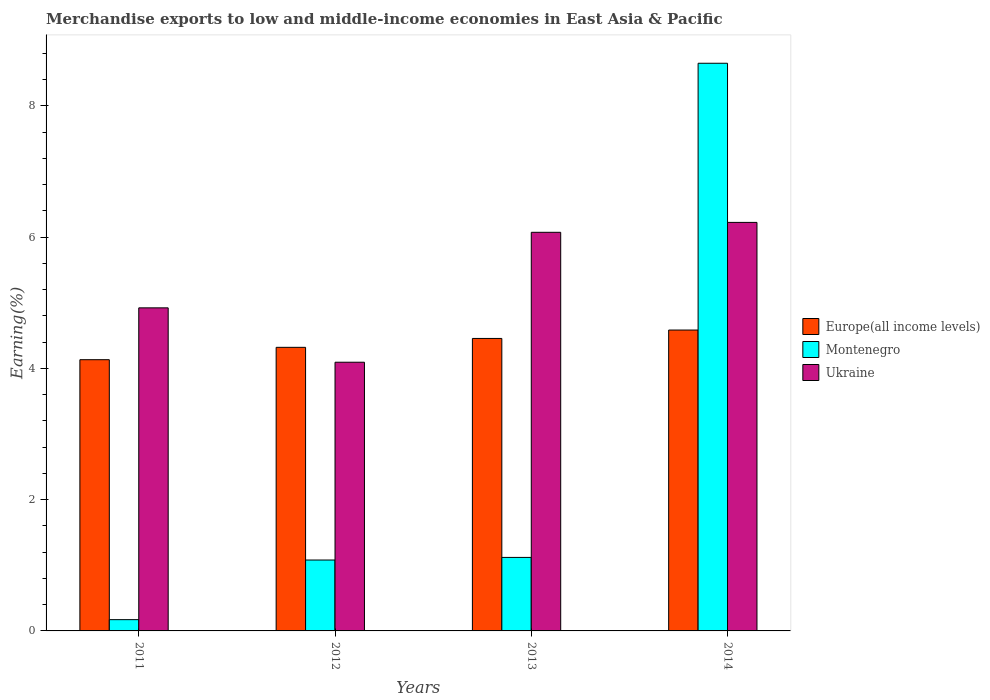How many different coloured bars are there?
Offer a terse response. 3. How many groups of bars are there?
Provide a short and direct response. 4. How many bars are there on the 1st tick from the right?
Make the answer very short. 3. What is the label of the 1st group of bars from the left?
Provide a short and direct response. 2011. What is the percentage of amount earned from merchandise exports in Ukraine in 2014?
Give a very brief answer. 6.23. Across all years, what is the maximum percentage of amount earned from merchandise exports in Montenegro?
Provide a succinct answer. 8.65. Across all years, what is the minimum percentage of amount earned from merchandise exports in Montenegro?
Your answer should be compact. 0.17. In which year was the percentage of amount earned from merchandise exports in Ukraine maximum?
Provide a succinct answer. 2014. In which year was the percentage of amount earned from merchandise exports in Ukraine minimum?
Ensure brevity in your answer.  2012. What is the total percentage of amount earned from merchandise exports in Europe(all income levels) in the graph?
Offer a very short reply. 17.5. What is the difference between the percentage of amount earned from merchandise exports in Europe(all income levels) in 2011 and that in 2013?
Give a very brief answer. -0.32. What is the difference between the percentage of amount earned from merchandise exports in Ukraine in 2014 and the percentage of amount earned from merchandise exports in Europe(all income levels) in 2012?
Offer a terse response. 1.9. What is the average percentage of amount earned from merchandise exports in Montenegro per year?
Give a very brief answer. 2.76. In the year 2014, what is the difference between the percentage of amount earned from merchandise exports in Europe(all income levels) and percentage of amount earned from merchandise exports in Ukraine?
Give a very brief answer. -1.64. In how many years, is the percentage of amount earned from merchandise exports in Montenegro greater than 1.2000000000000002 %?
Make the answer very short. 1. What is the ratio of the percentage of amount earned from merchandise exports in Europe(all income levels) in 2013 to that in 2014?
Provide a short and direct response. 0.97. What is the difference between the highest and the second highest percentage of amount earned from merchandise exports in Ukraine?
Provide a short and direct response. 0.15. What is the difference between the highest and the lowest percentage of amount earned from merchandise exports in Europe(all income levels)?
Provide a short and direct response. 0.45. What does the 1st bar from the left in 2012 represents?
Your answer should be very brief. Europe(all income levels). What does the 1st bar from the right in 2011 represents?
Your answer should be very brief. Ukraine. How many bars are there?
Offer a very short reply. 12. Are all the bars in the graph horizontal?
Offer a very short reply. No. How many years are there in the graph?
Offer a terse response. 4. What is the difference between two consecutive major ticks on the Y-axis?
Your response must be concise. 2. Does the graph contain grids?
Give a very brief answer. No. Where does the legend appear in the graph?
Keep it short and to the point. Center right. How many legend labels are there?
Keep it short and to the point. 3. How are the legend labels stacked?
Provide a succinct answer. Vertical. What is the title of the graph?
Give a very brief answer. Merchandise exports to low and middle-income economies in East Asia & Pacific. Does "Libya" appear as one of the legend labels in the graph?
Make the answer very short. No. What is the label or title of the X-axis?
Offer a terse response. Years. What is the label or title of the Y-axis?
Provide a succinct answer. Earning(%). What is the Earning(%) in Europe(all income levels) in 2011?
Your answer should be very brief. 4.13. What is the Earning(%) of Montenegro in 2011?
Keep it short and to the point. 0.17. What is the Earning(%) of Ukraine in 2011?
Offer a terse response. 4.92. What is the Earning(%) of Europe(all income levels) in 2012?
Provide a succinct answer. 4.32. What is the Earning(%) of Montenegro in 2012?
Give a very brief answer. 1.08. What is the Earning(%) of Ukraine in 2012?
Offer a very short reply. 4.09. What is the Earning(%) in Europe(all income levels) in 2013?
Your answer should be compact. 4.46. What is the Earning(%) of Montenegro in 2013?
Keep it short and to the point. 1.12. What is the Earning(%) in Ukraine in 2013?
Your answer should be very brief. 6.07. What is the Earning(%) of Europe(all income levels) in 2014?
Ensure brevity in your answer.  4.59. What is the Earning(%) in Montenegro in 2014?
Your response must be concise. 8.65. What is the Earning(%) in Ukraine in 2014?
Make the answer very short. 6.23. Across all years, what is the maximum Earning(%) of Europe(all income levels)?
Offer a terse response. 4.59. Across all years, what is the maximum Earning(%) in Montenegro?
Your answer should be compact. 8.65. Across all years, what is the maximum Earning(%) of Ukraine?
Provide a short and direct response. 6.23. Across all years, what is the minimum Earning(%) in Europe(all income levels)?
Your answer should be very brief. 4.13. Across all years, what is the minimum Earning(%) of Montenegro?
Your response must be concise. 0.17. Across all years, what is the minimum Earning(%) in Ukraine?
Provide a short and direct response. 4.09. What is the total Earning(%) in Europe(all income levels) in the graph?
Your response must be concise. 17.5. What is the total Earning(%) in Montenegro in the graph?
Keep it short and to the point. 11.02. What is the total Earning(%) in Ukraine in the graph?
Offer a very short reply. 21.32. What is the difference between the Earning(%) of Europe(all income levels) in 2011 and that in 2012?
Offer a very short reply. -0.19. What is the difference between the Earning(%) of Montenegro in 2011 and that in 2012?
Give a very brief answer. -0.91. What is the difference between the Earning(%) of Ukraine in 2011 and that in 2012?
Your answer should be compact. 0.83. What is the difference between the Earning(%) in Europe(all income levels) in 2011 and that in 2013?
Offer a very short reply. -0.32. What is the difference between the Earning(%) of Montenegro in 2011 and that in 2013?
Give a very brief answer. -0.95. What is the difference between the Earning(%) in Ukraine in 2011 and that in 2013?
Keep it short and to the point. -1.15. What is the difference between the Earning(%) in Europe(all income levels) in 2011 and that in 2014?
Give a very brief answer. -0.45. What is the difference between the Earning(%) of Montenegro in 2011 and that in 2014?
Keep it short and to the point. -8.48. What is the difference between the Earning(%) in Ukraine in 2011 and that in 2014?
Provide a short and direct response. -1.3. What is the difference between the Earning(%) of Europe(all income levels) in 2012 and that in 2013?
Provide a short and direct response. -0.14. What is the difference between the Earning(%) in Montenegro in 2012 and that in 2013?
Your response must be concise. -0.04. What is the difference between the Earning(%) in Ukraine in 2012 and that in 2013?
Your answer should be very brief. -1.98. What is the difference between the Earning(%) in Europe(all income levels) in 2012 and that in 2014?
Keep it short and to the point. -0.26. What is the difference between the Earning(%) in Montenegro in 2012 and that in 2014?
Offer a terse response. -7.57. What is the difference between the Earning(%) of Ukraine in 2012 and that in 2014?
Your answer should be very brief. -2.13. What is the difference between the Earning(%) of Europe(all income levels) in 2013 and that in 2014?
Keep it short and to the point. -0.13. What is the difference between the Earning(%) of Montenegro in 2013 and that in 2014?
Ensure brevity in your answer.  -7.53. What is the difference between the Earning(%) of Ukraine in 2013 and that in 2014?
Your response must be concise. -0.15. What is the difference between the Earning(%) in Europe(all income levels) in 2011 and the Earning(%) in Montenegro in 2012?
Ensure brevity in your answer.  3.05. What is the difference between the Earning(%) of Europe(all income levels) in 2011 and the Earning(%) of Ukraine in 2012?
Your response must be concise. 0.04. What is the difference between the Earning(%) of Montenegro in 2011 and the Earning(%) of Ukraine in 2012?
Give a very brief answer. -3.92. What is the difference between the Earning(%) of Europe(all income levels) in 2011 and the Earning(%) of Montenegro in 2013?
Provide a short and direct response. 3.01. What is the difference between the Earning(%) of Europe(all income levels) in 2011 and the Earning(%) of Ukraine in 2013?
Give a very brief answer. -1.94. What is the difference between the Earning(%) in Montenegro in 2011 and the Earning(%) in Ukraine in 2013?
Offer a terse response. -5.9. What is the difference between the Earning(%) in Europe(all income levels) in 2011 and the Earning(%) in Montenegro in 2014?
Your response must be concise. -4.52. What is the difference between the Earning(%) in Europe(all income levels) in 2011 and the Earning(%) in Ukraine in 2014?
Provide a succinct answer. -2.09. What is the difference between the Earning(%) in Montenegro in 2011 and the Earning(%) in Ukraine in 2014?
Keep it short and to the point. -6.05. What is the difference between the Earning(%) in Europe(all income levels) in 2012 and the Earning(%) in Montenegro in 2013?
Provide a succinct answer. 3.2. What is the difference between the Earning(%) in Europe(all income levels) in 2012 and the Earning(%) in Ukraine in 2013?
Offer a terse response. -1.75. What is the difference between the Earning(%) of Montenegro in 2012 and the Earning(%) of Ukraine in 2013?
Your answer should be very brief. -4.99. What is the difference between the Earning(%) in Europe(all income levels) in 2012 and the Earning(%) in Montenegro in 2014?
Make the answer very short. -4.33. What is the difference between the Earning(%) of Europe(all income levels) in 2012 and the Earning(%) of Ukraine in 2014?
Give a very brief answer. -1.9. What is the difference between the Earning(%) of Montenegro in 2012 and the Earning(%) of Ukraine in 2014?
Make the answer very short. -5.15. What is the difference between the Earning(%) of Europe(all income levels) in 2013 and the Earning(%) of Montenegro in 2014?
Make the answer very short. -4.19. What is the difference between the Earning(%) in Europe(all income levels) in 2013 and the Earning(%) in Ukraine in 2014?
Your response must be concise. -1.77. What is the difference between the Earning(%) of Montenegro in 2013 and the Earning(%) of Ukraine in 2014?
Your answer should be very brief. -5.11. What is the average Earning(%) in Europe(all income levels) per year?
Keep it short and to the point. 4.37. What is the average Earning(%) of Montenegro per year?
Make the answer very short. 2.76. What is the average Earning(%) in Ukraine per year?
Keep it short and to the point. 5.33. In the year 2011, what is the difference between the Earning(%) of Europe(all income levels) and Earning(%) of Montenegro?
Make the answer very short. 3.96. In the year 2011, what is the difference between the Earning(%) of Europe(all income levels) and Earning(%) of Ukraine?
Provide a short and direct response. -0.79. In the year 2011, what is the difference between the Earning(%) of Montenegro and Earning(%) of Ukraine?
Offer a very short reply. -4.75. In the year 2012, what is the difference between the Earning(%) of Europe(all income levels) and Earning(%) of Montenegro?
Your answer should be compact. 3.24. In the year 2012, what is the difference between the Earning(%) of Europe(all income levels) and Earning(%) of Ukraine?
Provide a succinct answer. 0.23. In the year 2012, what is the difference between the Earning(%) of Montenegro and Earning(%) of Ukraine?
Provide a succinct answer. -3.01. In the year 2013, what is the difference between the Earning(%) of Europe(all income levels) and Earning(%) of Montenegro?
Offer a terse response. 3.34. In the year 2013, what is the difference between the Earning(%) of Europe(all income levels) and Earning(%) of Ukraine?
Provide a succinct answer. -1.62. In the year 2013, what is the difference between the Earning(%) in Montenegro and Earning(%) in Ukraine?
Keep it short and to the point. -4.95. In the year 2014, what is the difference between the Earning(%) in Europe(all income levels) and Earning(%) in Montenegro?
Your response must be concise. -4.07. In the year 2014, what is the difference between the Earning(%) of Europe(all income levels) and Earning(%) of Ukraine?
Ensure brevity in your answer.  -1.64. In the year 2014, what is the difference between the Earning(%) of Montenegro and Earning(%) of Ukraine?
Provide a short and direct response. 2.43. What is the ratio of the Earning(%) in Europe(all income levels) in 2011 to that in 2012?
Provide a short and direct response. 0.96. What is the ratio of the Earning(%) of Montenegro in 2011 to that in 2012?
Ensure brevity in your answer.  0.16. What is the ratio of the Earning(%) of Ukraine in 2011 to that in 2012?
Provide a short and direct response. 1.2. What is the ratio of the Earning(%) in Europe(all income levels) in 2011 to that in 2013?
Ensure brevity in your answer.  0.93. What is the ratio of the Earning(%) of Montenegro in 2011 to that in 2013?
Your response must be concise. 0.15. What is the ratio of the Earning(%) in Ukraine in 2011 to that in 2013?
Offer a terse response. 0.81. What is the ratio of the Earning(%) in Europe(all income levels) in 2011 to that in 2014?
Provide a short and direct response. 0.9. What is the ratio of the Earning(%) in Montenegro in 2011 to that in 2014?
Your answer should be very brief. 0.02. What is the ratio of the Earning(%) of Ukraine in 2011 to that in 2014?
Give a very brief answer. 0.79. What is the ratio of the Earning(%) in Europe(all income levels) in 2012 to that in 2013?
Your response must be concise. 0.97. What is the ratio of the Earning(%) of Montenegro in 2012 to that in 2013?
Offer a very short reply. 0.96. What is the ratio of the Earning(%) in Ukraine in 2012 to that in 2013?
Offer a terse response. 0.67. What is the ratio of the Earning(%) of Europe(all income levels) in 2012 to that in 2014?
Make the answer very short. 0.94. What is the ratio of the Earning(%) in Montenegro in 2012 to that in 2014?
Provide a short and direct response. 0.12. What is the ratio of the Earning(%) in Ukraine in 2012 to that in 2014?
Give a very brief answer. 0.66. What is the ratio of the Earning(%) in Europe(all income levels) in 2013 to that in 2014?
Give a very brief answer. 0.97. What is the ratio of the Earning(%) in Montenegro in 2013 to that in 2014?
Your answer should be compact. 0.13. What is the ratio of the Earning(%) in Ukraine in 2013 to that in 2014?
Offer a very short reply. 0.98. What is the difference between the highest and the second highest Earning(%) in Europe(all income levels)?
Make the answer very short. 0.13. What is the difference between the highest and the second highest Earning(%) in Montenegro?
Keep it short and to the point. 7.53. What is the difference between the highest and the second highest Earning(%) of Ukraine?
Keep it short and to the point. 0.15. What is the difference between the highest and the lowest Earning(%) of Europe(all income levels)?
Provide a succinct answer. 0.45. What is the difference between the highest and the lowest Earning(%) of Montenegro?
Your answer should be compact. 8.48. What is the difference between the highest and the lowest Earning(%) in Ukraine?
Your answer should be compact. 2.13. 